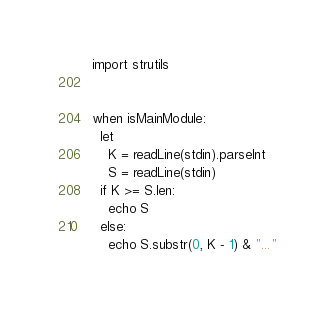<code> <loc_0><loc_0><loc_500><loc_500><_Nim_>import strutils
  

when isMainModule:
  let
    K = readLine(stdin).parseInt
    S = readLine(stdin)
  if K >= S.len:
    echo S
  else:
    echo S.substr(0, K - 1) & "..."</code> 